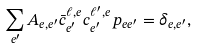<formula> <loc_0><loc_0><loc_500><loc_500>\sum _ { e ^ { \prime } } A _ { e , e ^ { \prime } } \bar { c } ^ { \ell , e } _ { e ^ { \prime } } c ^ { \ell ^ { \prime } , e } _ { e ^ { \prime } } p _ { e e ^ { \prime } } = \delta _ { e , e ^ { \prime } } ,</formula> 